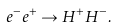<formula> <loc_0><loc_0><loc_500><loc_500>e ^ { - } e ^ { + } \to H ^ { + } H ^ { - } .</formula> 